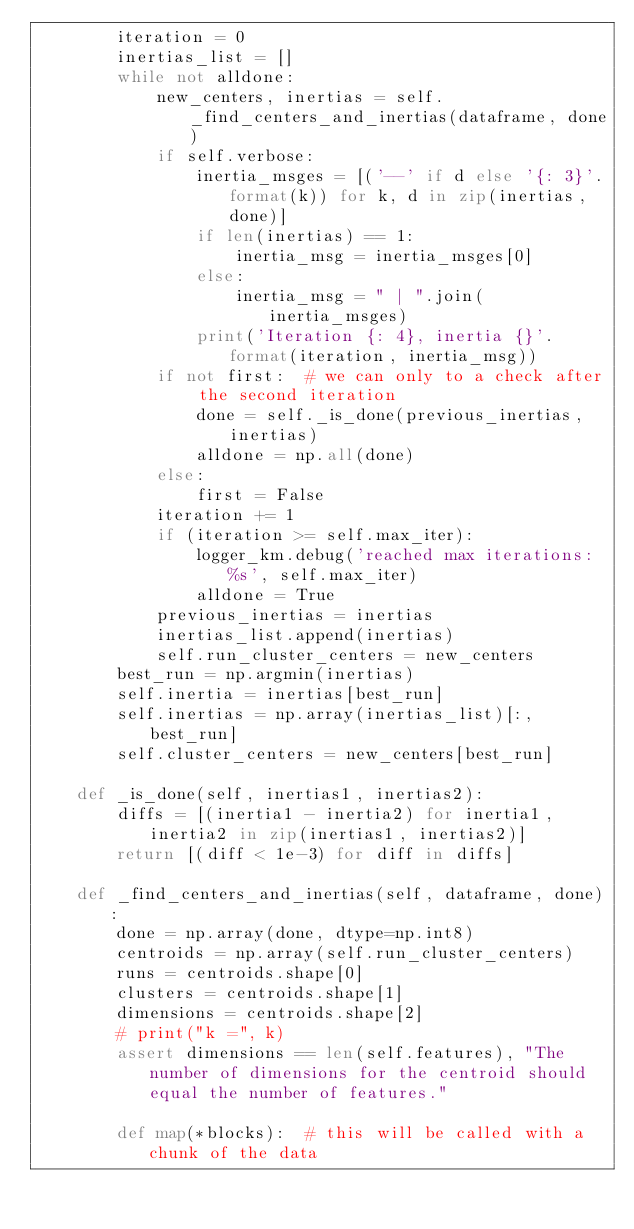<code> <loc_0><loc_0><loc_500><loc_500><_Python_>        iteration = 0
        inertias_list = []
        while not alldone:
            new_centers, inertias = self._find_centers_and_inertias(dataframe, done)
            if self.verbose:
                inertia_msges = [('--' if d else '{: 3}'.format(k)) for k, d in zip(inertias, done)]
                if len(inertias) == 1:
                    inertia_msg = inertia_msges[0]
                else:
                    inertia_msg = " | ".join(inertia_msges)
                print('Iteration {: 4}, inertia {}'.format(iteration, inertia_msg))
            if not first:  # we can only to a check after the second iteration
                done = self._is_done(previous_inertias, inertias)
                alldone = np.all(done)
            else:
                first = False
            iteration += 1
            if (iteration >= self.max_iter):
                logger_km.debug('reached max iterations: %s', self.max_iter)
                alldone = True
            previous_inertias = inertias
            inertias_list.append(inertias)
            self.run_cluster_centers = new_centers
        best_run = np.argmin(inertias)
        self.inertia = inertias[best_run]
        self.inertias = np.array(inertias_list)[:, best_run]
        self.cluster_centers = new_centers[best_run]

    def _is_done(self, inertias1, inertias2):
        diffs = [(inertia1 - inertia2) for inertia1, inertia2 in zip(inertias1, inertias2)]
        return [(diff < 1e-3) for diff in diffs]

    def _find_centers_and_inertias(self, dataframe, done):
        done = np.array(done, dtype=np.int8)
        centroids = np.array(self.run_cluster_centers)
        runs = centroids.shape[0]
        clusters = centroids.shape[1]
        dimensions = centroids.shape[2]
        # print("k =", k)
        assert dimensions == len(self.features), "The number of dimensions for the centroid should equal the number of features."

        def map(*blocks):  # this will be called with a chunk of the data</code> 